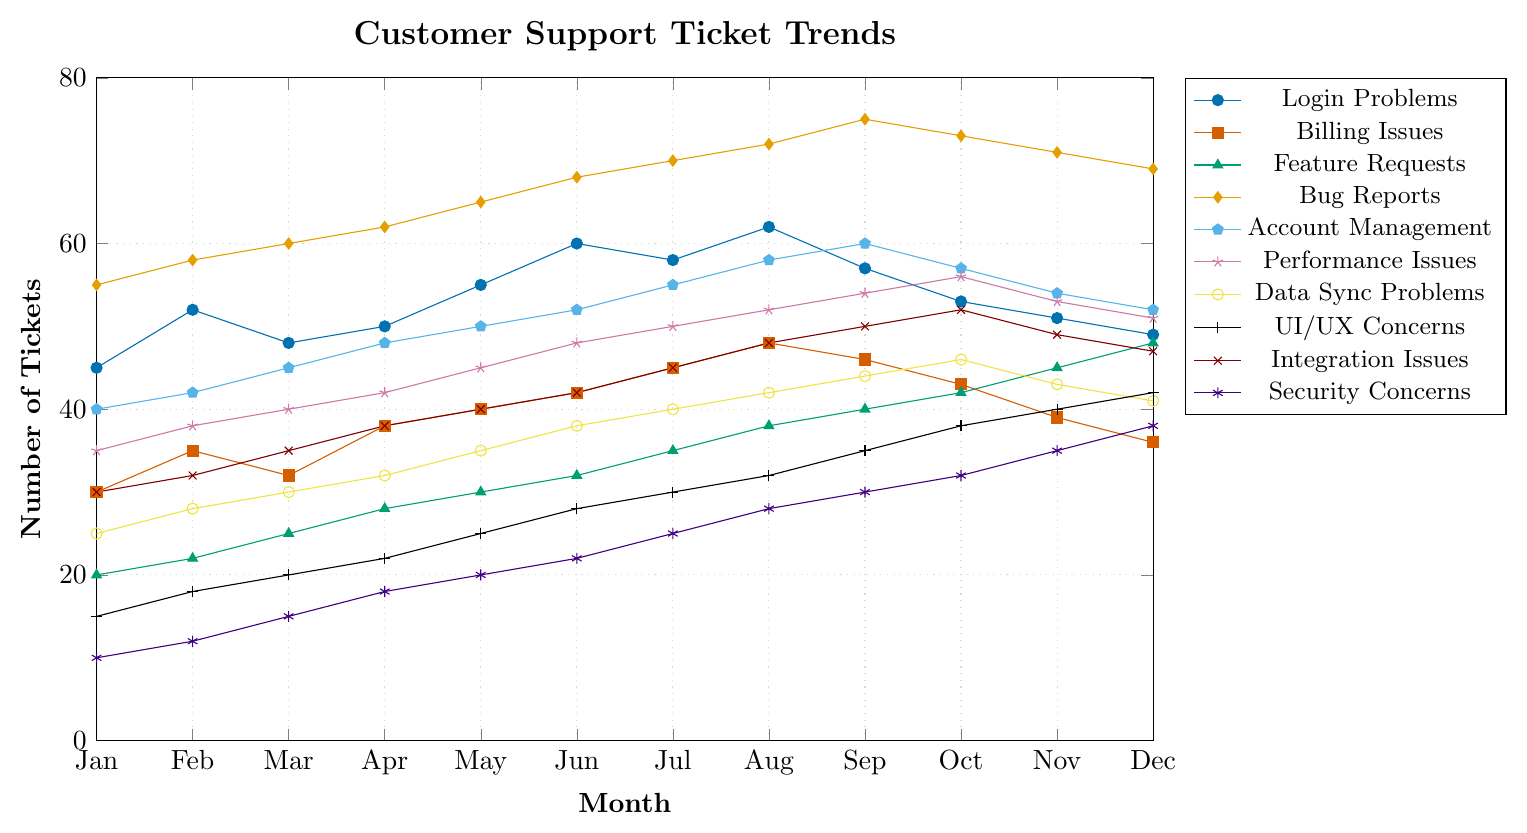Which issue type had the highest number of tickets in September? Look for the peak in the lines for the month of September (x=8). The highest value is found in the Bug Reports line.
Answer: Bug Reports Which months experienced the highest and lowest number of tickets for Security Concerns? Identify the peaks and troughs for the Security Concerns line. The highest is in December (38 tickets) and the lowest is in January (10 tickets).
Answer: December, January During which months did Billing Issues report more tickets than Feature Requests? Compare the tickets each month. Billing Issues reported more tickets in Jan, Feb, Mar, Apr, May, Jun, Jul, Aug, Sep, Oct.
Answer: January to October What's the average number of tickets for UI/UX Concerns throughout the year? Sum the monthly values for UI/UX Concerns (15 + 18 + 20 + 22 + 25 + 28 + 30 + 32 + 35 + 38 + 40 + 42 = 345) and divide by 12.
Answer: 28.75 Which issue type has the fastest resolution time and how many tickets were created in its highest month? Identify the issue type with the smallest resolution time (Login Problems, 2 hours). The highest number of tickets for Login Problems is in August (62 tickets).
Answer: Login Problems, 62 Of all the months, which month saw the highest ticket volume for all issue types combined? Calculate the monthly totals and find the highest value. August has the highest volume.
Answer: August Are there any issue types with an increasing trend throughout the year? Look for lines that consistently rise from January to December. Feature Requests and Security Concerns increase steadily.
Answer: Feature Requests, Security Concerns For which months do Integration Issues and Performance Issues have the same number of tickets? Compare the two lines month by month to find when they share the same value. They are equal in November (49 tickets each).
Answer: November What's the total number of tickets for Bug Reports in the second half of the year? Sum the tickets for Bug Reports from July to December (70 + 72 + 75 + 73 + 71 + 69 = 430).
Answer: 430 Compare the peak numbers of tickets for Data Sync Problems and UI/UX Concerns. Which is higher and by how much? Check the maximum values: Data Sync Problems (46 tickets), UI/UX Concerns (42 tickets). The difference is 4 tickets.
Answer: Data Sync Problems, 4 